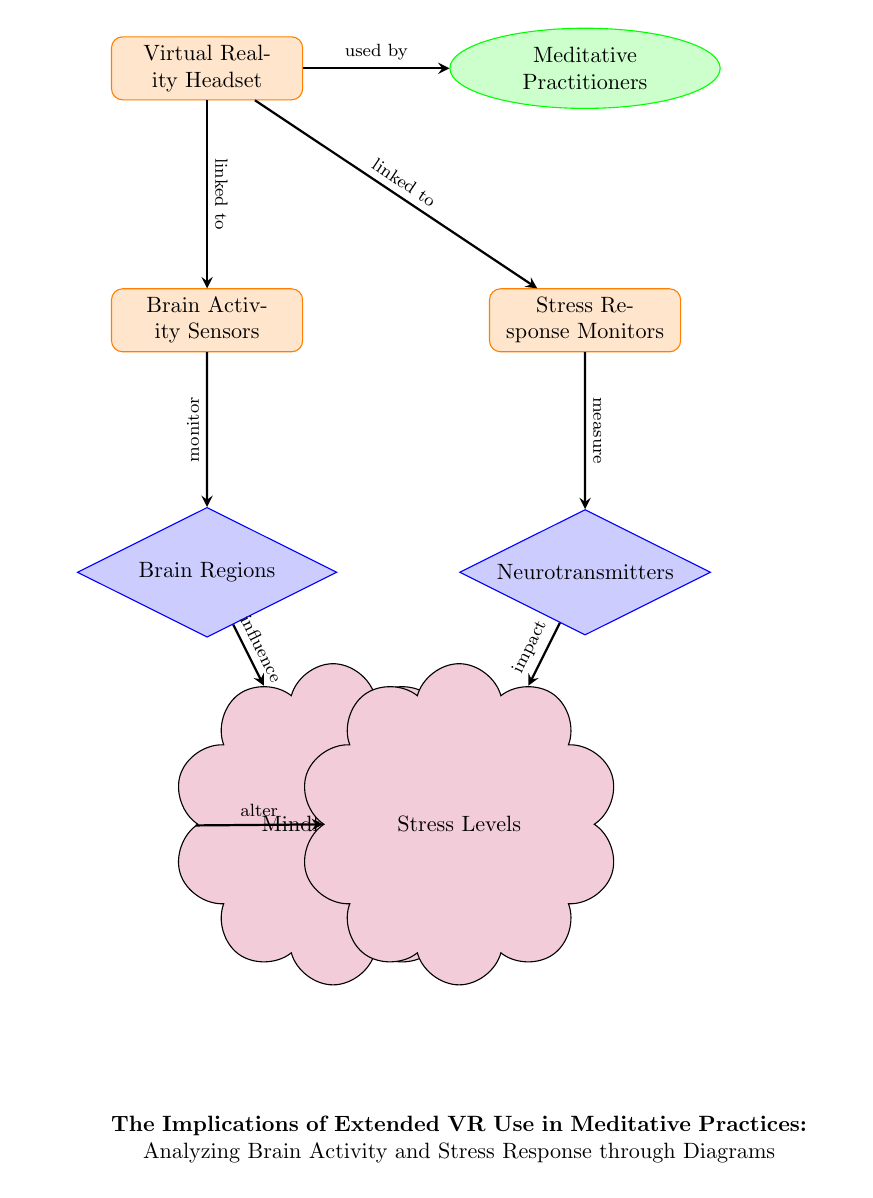What is the device used by meditative practitioners? The diagram clearly labels the device as "Virtual Reality Headset" connected to the "Meditative Practitioners" node, indicating their use of this technology.
Answer: Virtual Reality Headset What is monitored by the brain activity sensors? The brain activity sensors are linked to the "Brain Regions" node, which indicates that these sensors are responsible for monitoring brain activity.
Answer: Brain Regions How many main components are in the diagram? Counting the nodes in the diagram reveals 7 components: Virtual Reality Headset, Meditative Practitioners, Brain Activity Sensors, Stress Response Monitors, Brain Regions, Neurotransmitters, Mindful States, and Stress Levels.
Answer: 7 What influences mindful states according to the diagram? The arrow indicates that "Brain Regions" influence "Mindful States," showing the relationship between these two components of the diagram.
Answer: Brain Regions What is the relationship between stress response monitors and neurotransmitters? The diagram shows a direct connection where stress response monitors "measure" neurotransmitters, indicating a relationship where one component assesses the other.
Answer: Measure Which component impacts stress levels? According to the diagram, the arrow shows that "Neurotransmitters" impact "Stress Levels," demonstrating a direct effect between these two nodes.
Answer: Neurotransmitters What is the additional effect that mindful states have on stress levels? There is an arrow indicating that "Mindful States" alter "Stress Levels," highlighting that changes in psychological conditions can influence stress responses.
Answer: Alter What connects virtual reality headset to brain activity sensors? The diagram specifies that the "Virtual Reality Headset" is "linked to" the "Brain Activity Sensors," establishing a direct connection between these two components.
Answer: Linked to What connects stress response monitors to brain activity sensors? The diagram indicates that "Virtual Reality Headset" is also "linked to" the "Stress Response Monitors," establishing a similar connection for monitoring.
Answer: Linked to 